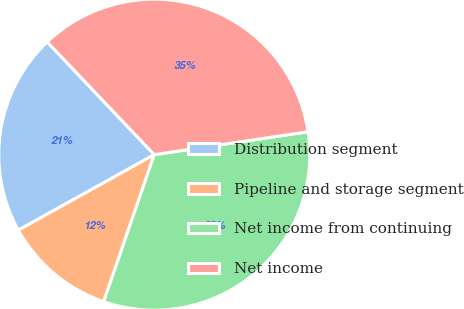<chart> <loc_0><loc_0><loc_500><loc_500><pie_chart><fcel>Distribution segment<fcel>Pipeline and storage segment<fcel>Net income from continuing<fcel>Net income<nl><fcel>20.98%<fcel>11.65%<fcel>32.63%<fcel>34.73%<nl></chart> 